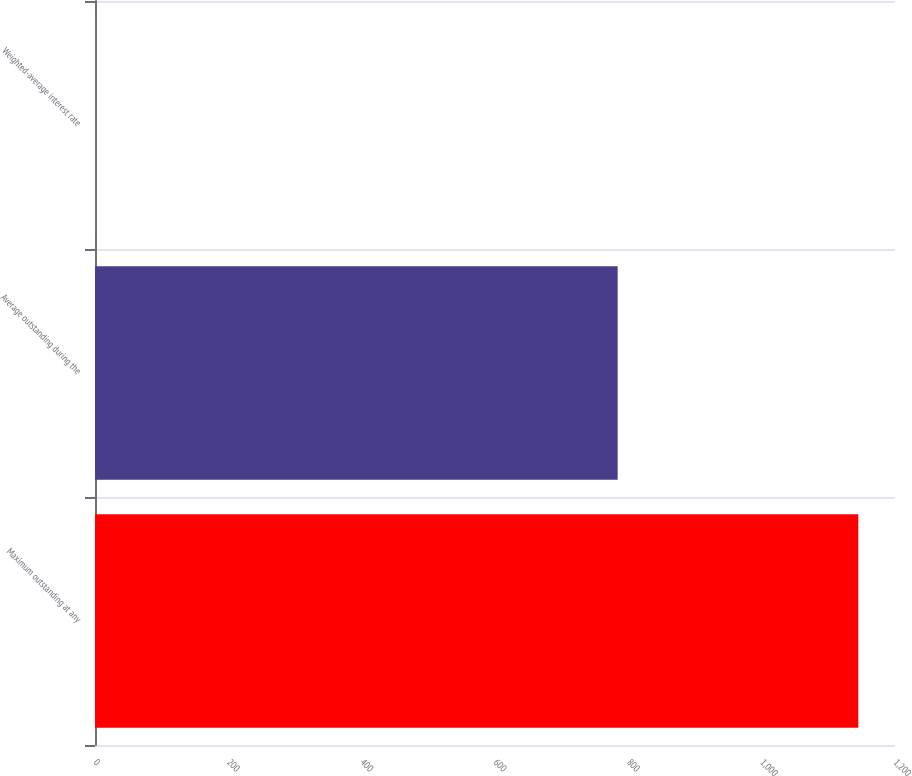Convert chart to OTSL. <chart><loc_0><loc_0><loc_500><loc_500><bar_chart><fcel>Maximum outstanding at any<fcel>Average outstanding during the<fcel>Weighted-average interest rate<nl><fcel>1145<fcel>784<fcel>0.09<nl></chart> 